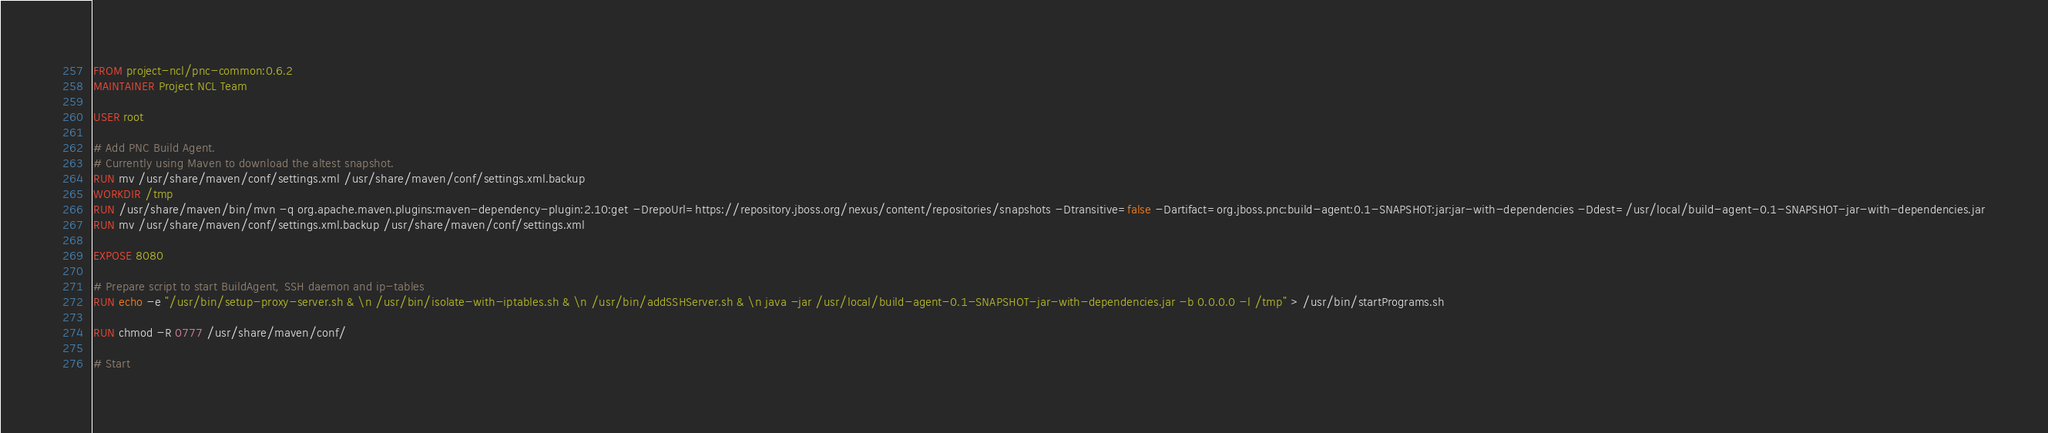Convert code to text. <code><loc_0><loc_0><loc_500><loc_500><_Dockerfile_>FROM project-ncl/pnc-common:0.6.2
MAINTAINER Project NCL Team

USER root

# Add PNC Build Agent.
# Currently using Maven to download the altest snapshot.
RUN mv /usr/share/maven/conf/settings.xml /usr/share/maven/conf/settings.xml.backup
WORKDIR /tmp
RUN /usr/share/maven/bin/mvn -q org.apache.maven.plugins:maven-dependency-plugin:2.10:get -DrepoUrl=https://repository.jboss.org/nexus/content/repositories/snapshots -Dtransitive=false -Dartifact=org.jboss.pnc:build-agent:0.1-SNAPSHOT:jar:jar-with-dependencies -Ddest=/usr/local/build-agent-0.1-SNAPSHOT-jar-with-dependencies.jar
RUN mv /usr/share/maven/conf/settings.xml.backup /usr/share/maven/conf/settings.xml

EXPOSE 8080

# Prepare script to start BuildAgent, SSH daemon and ip-tables
RUN echo -e "/usr/bin/setup-proxy-server.sh & \n /usr/bin/isolate-with-iptables.sh & \n /usr/bin/addSSHServer.sh & \n java -jar /usr/local/build-agent-0.1-SNAPSHOT-jar-with-dependencies.jar -b 0.0.0.0 -l /tmp" > /usr/bin/startPrograms.sh

RUN chmod -R 0777 /usr/share/maven/conf/

# Start</code> 